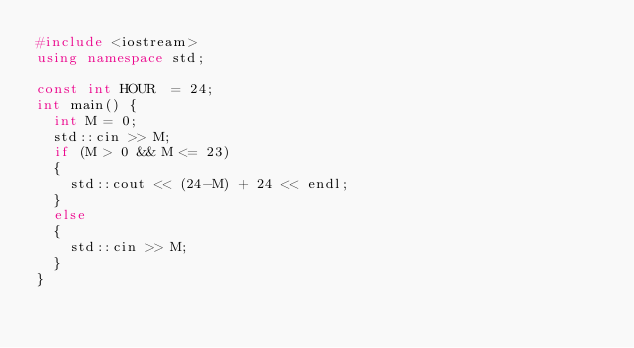Convert code to text. <code><loc_0><loc_0><loc_500><loc_500><_C++_>#include <iostream>
using namespace std;

const int HOUR  = 24;
int main() {
	int M = 0;
	std::cin >> M;
	if (M > 0 && M <= 23)
	{
		std::cout << (24-M) + 24 << endl;
	}
	else
	{
		std::cin >> M;
	}
}</code> 